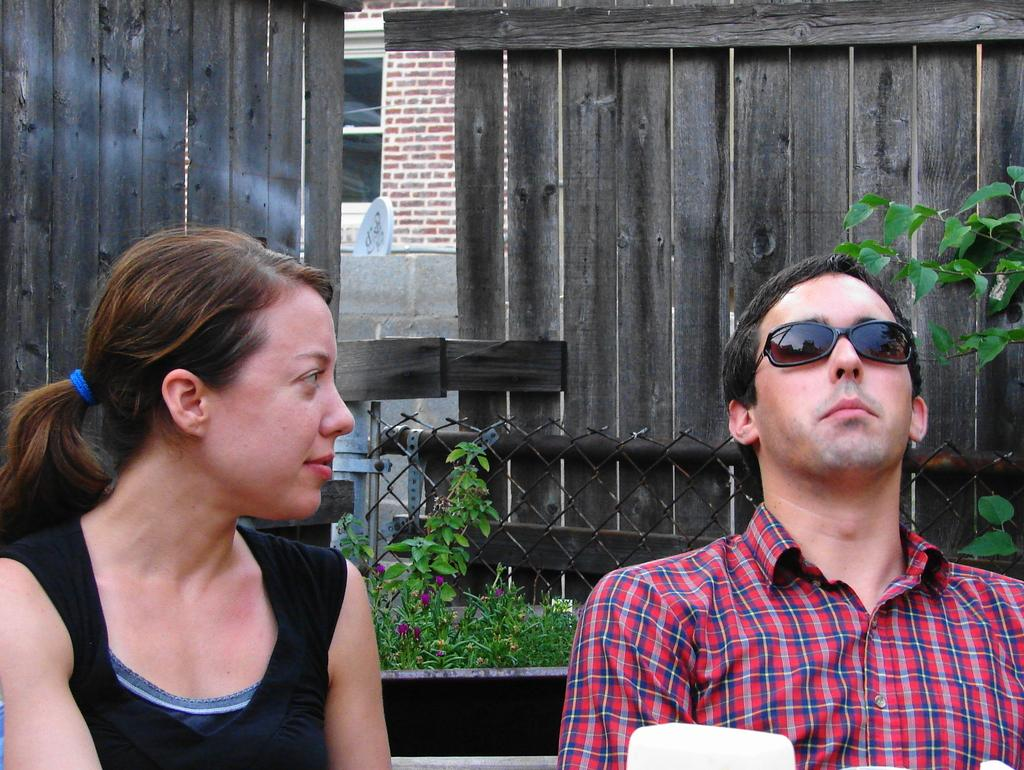What are the two people in the image doing? There is a man and a woman sitting in the image. What can be seen in the background of the image? There are plants with flowers, a metal fence, a wall, a dish, and a board with text in the background. What type of cream is being used to write on the letter in the image? There is no letter or cream present in the image. How many screws can be seen holding the board in the image? There is no board with screws present in the image. 